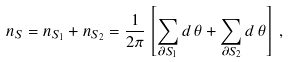Convert formula to latex. <formula><loc_0><loc_0><loc_500><loc_500>n _ { S } = n _ { S _ { 1 } } + n _ { S _ { 2 } } = \frac { 1 } { 2 \pi } \left [ \sum _ { \partial S _ { 1 } } d \, \theta + \sum _ { \partial S _ { 2 } } d \, \theta \right ] \, , \,</formula> 